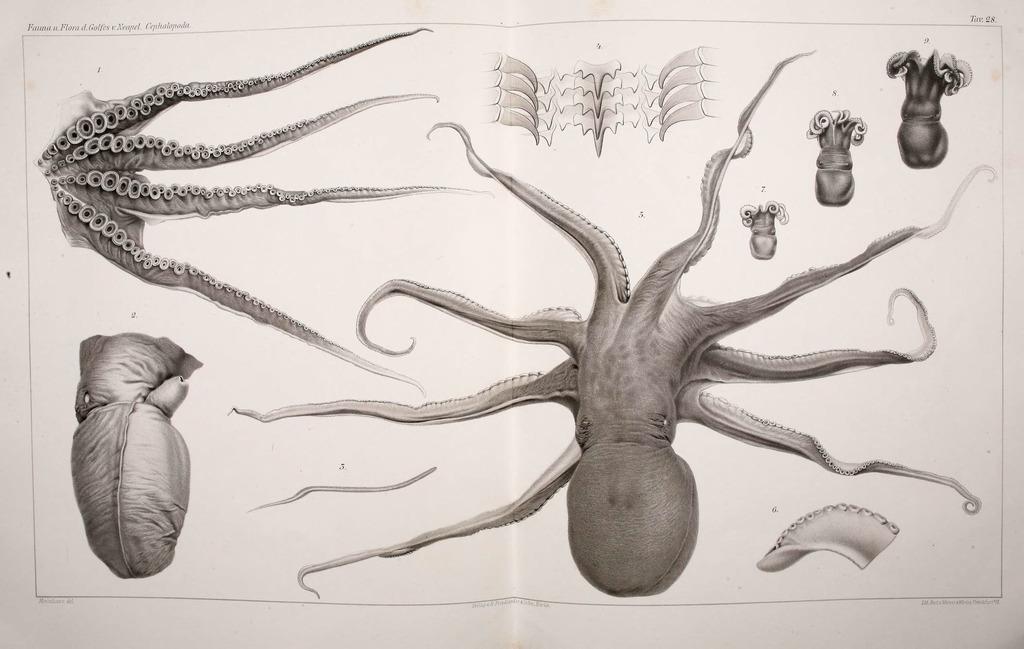How would you summarize this image in a sentence or two? This is a picture of a poster with some information. We can see water animals and its parts. 